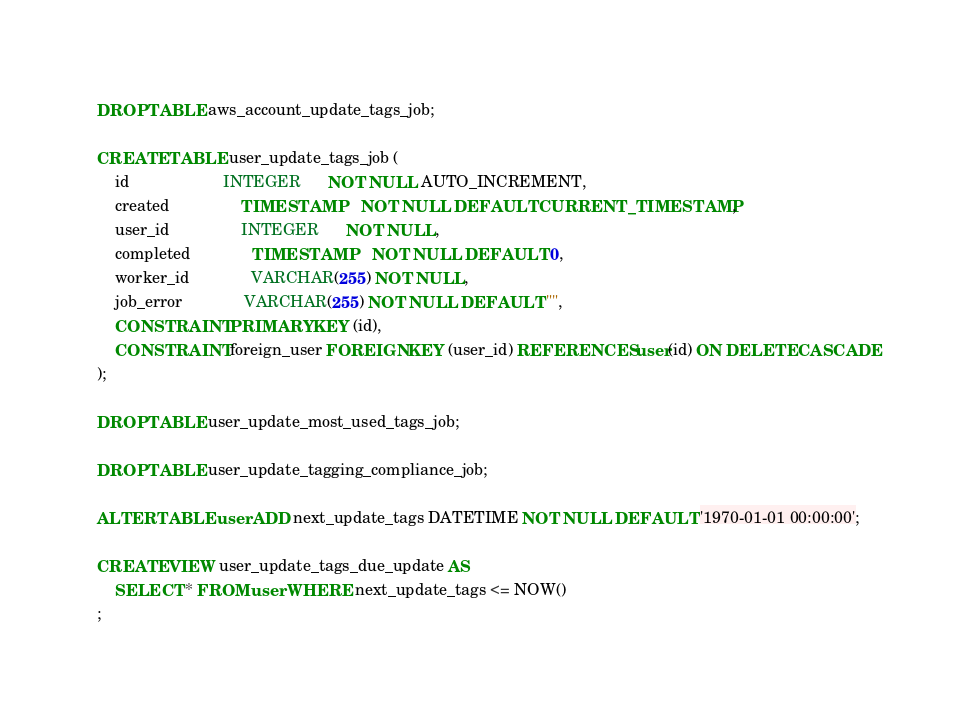Convert code to text. <code><loc_0><loc_0><loc_500><loc_500><_SQL_>
DROP TABLE aws_account_update_tags_job;

CREATE TABLE user_update_tags_job (
	id                     INTEGER      NOT NULL AUTO_INCREMENT,
	created                TIMESTAMP    NOT NULL DEFAULT CURRENT_TIMESTAMP,
	user_id                INTEGER      NOT NULL,
	completed              TIMESTAMP    NOT NULL DEFAULT 0,
	worker_id              VARCHAR(255) NOT NULL,
	job_error              VARCHAR(255) NOT NULL DEFAULT "",
	CONSTRAINT PRIMARY KEY (id),
	CONSTRAINT foreign_user FOREIGN KEY (user_id) REFERENCES user(id) ON DELETE CASCADE
);

DROP TABLE user_update_most_used_tags_job;

DROP TABLE user_update_tagging_compliance_job;

ALTER TABLE user ADD next_update_tags DATETIME NOT NULL DEFAULT '1970-01-01 00:00:00';

CREATE VIEW user_update_tags_due_update AS
	SELECT * FROM user WHERE next_update_tags <= NOW()
;
</code> 